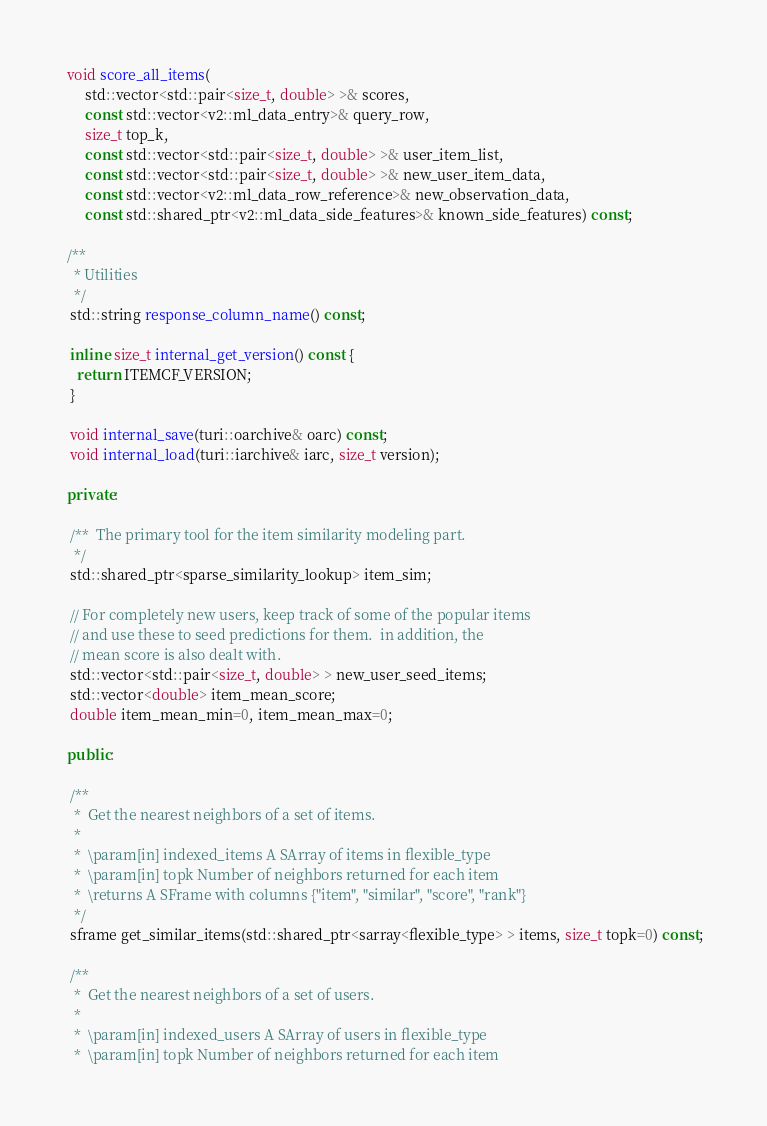Convert code to text. <code><loc_0><loc_0><loc_500><loc_500><_C++_> void score_all_items(
      std::vector<std::pair<size_t, double> >& scores,
      const std::vector<v2::ml_data_entry>& query_row,
      size_t top_k,
      const std::vector<std::pair<size_t, double> >& user_item_list,
      const std::vector<std::pair<size_t, double> >& new_user_item_data,
      const std::vector<v2::ml_data_row_reference>& new_observation_data,
      const std::shared_ptr<v2::ml_data_side_features>& known_side_features) const;
  
 /**
   * Utilities
   */
  std::string response_column_name() const;

  inline size_t internal_get_version() const {
    return ITEMCF_VERSION;
  }

  void internal_save(turi::oarchive& oarc) const;
  void internal_load(turi::iarchive& iarc, size_t version);

 private:

  /**  The primary tool for the item similarity modeling part.
   */
  std::shared_ptr<sparse_similarity_lookup> item_sim;

  // For completely new users, keep track of some of the popular items
  // and use these to seed predictions for them.  in addition, the
  // mean score is also dealt with. 
  std::vector<std::pair<size_t, double> > new_user_seed_items;
  std::vector<double> item_mean_score;
  double item_mean_min=0, item_mean_max=0; 
  
 public:

  /**
   *  Get the nearest neighbors of a set of items.
   *  
   *  \param[in] indexed_items A SArray of items in flexible_type
   *  \param[in] topk Number of neighbors returned for each item
   *  \returns A SFrame with columns {"item", "similar", "score", "rank"}
   */
  sframe get_similar_items(std::shared_ptr<sarray<flexible_type> > items, size_t topk=0) const;

  /**
   *  Get the nearest neighbors of a set of users.
   *
   *  \param[in] indexed_users A SArray of users in flexible_type
   *  \param[in] topk Number of neighbors returned for each item</code> 